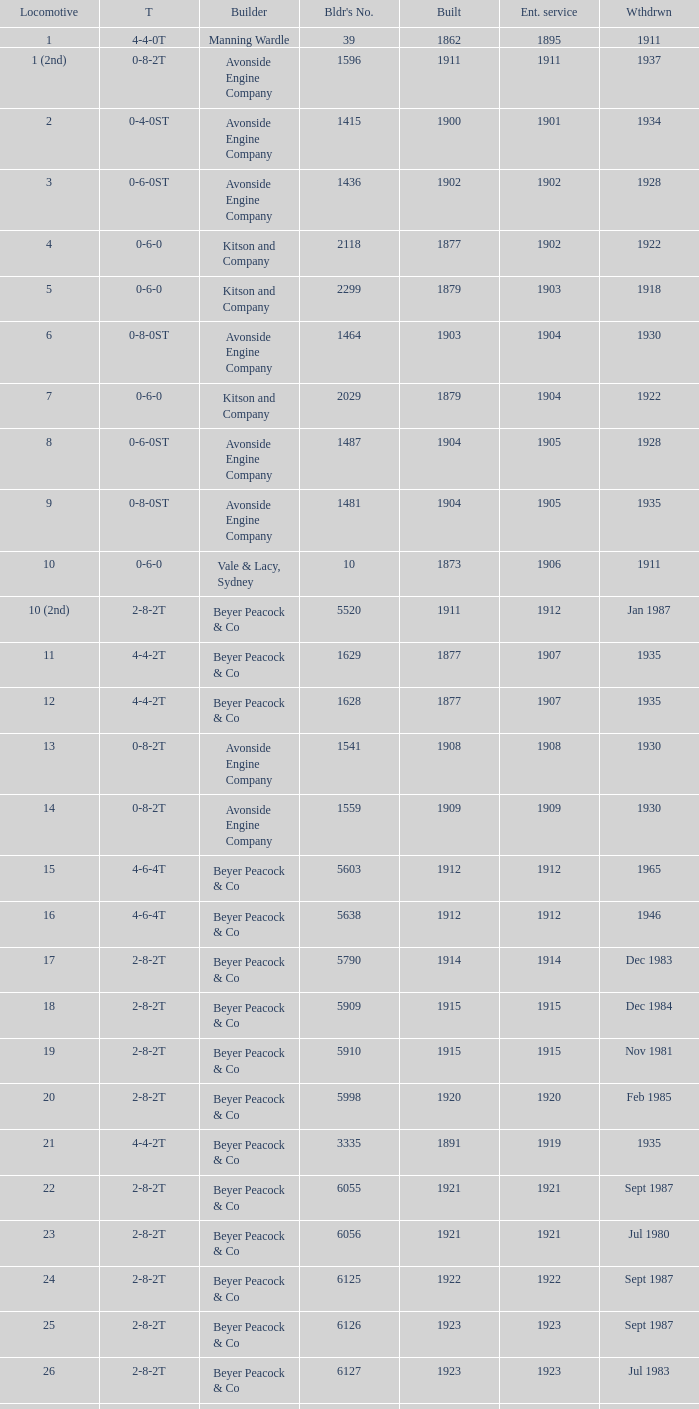Could you parse the entire table as a dict? {'header': ['Locomotive', 'T', 'Builder', "Bldr's No.", 'Built', 'Ent. service', 'Wthdrwn'], 'rows': [['1', '4-4-0T', 'Manning Wardle', '39', '1862', '1895', '1911'], ['1 (2nd)', '0-8-2T', 'Avonside Engine Company', '1596', '1911', '1911', '1937'], ['2', '0-4-0ST', 'Avonside Engine Company', '1415', '1900', '1901', '1934'], ['3', '0-6-0ST', 'Avonside Engine Company', '1436', '1902', '1902', '1928'], ['4', '0-6-0', 'Kitson and Company', '2118', '1877', '1902', '1922'], ['5', '0-6-0', 'Kitson and Company', '2299', '1879', '1903', '1918'], ['6', '0-8-0ST', 'Avonside Engine Company', '1464', '1903', '1904', '1930'], ['7', '0-6-0', 'Kitson and Company', '2029', '1879', '1904', '1922'], ['8', '0-6-0ST', 'Avonside Engine Company', '1487', '1904', '1905', '1928'], ['9', '0-8-0ST', 'Avonside Engine Company', '1481', '1904', '1905', '1935'], ['10', '0-6-0', 'Vale & Lacy, Sydney', '10', '1873', '1906', '1911'], ['10 (2nd)', '2-8-2T', 'Beyer Peacock & Co', '5520', '1911', '1912', 'Jan 1987'], ['11', '4-4-2T', 'Beyer Peacock & Co', '1629', '1877', '1907', '1935'], ['12', '4-4-2T', 'Beyer Peacock & Co', '1628', '1877', '1907', '1935'], ['13', '0-8-2T', 'Avonside Engine Company', '1541', '1908', '1908', '1930'], ['14', '0-8-2T', 'Avonside Engine Company', '1559', '1909', '1909', '1930'], ['15', '4-6-4T', 'Beyer Peacock & Co', '5603', '1912', '1912', '1965'], ['16', '4-6-4T', 'Beyer Peacock & Co', '5638', '1912', '1912', '1946'], ['17', '2-8-2T', 'Beyer Peacock & Co', '5790', '1914', '1914', 'Dec 1983'], ['18', '2-8-2T', 'Beyer Peacock & Co', '5909', '1915', '1915', 'Dec 1984'], ['19', '2-8-2T', 'Beyer Peacock & Co', '5910', '1915', '1915', 'Nov 1981'], ['20', '2-8-2T', 'Beyer Peacock & Co', '5998', '1920', '1920', 'Feb 1985'], ['21', '4-4-2T', 'Beyer Peacock & Co', '3335', '1891', '1919', '1935'], ['22', '2-8-2T', 'Beyer Peacock & Co', '6055', '1921', '1921', 'Sept 1987'], ['23', '2-8-2T', 'Beyer Peacock & Co', '6056', '1921', '1921', 'Jul 1980'], ['24', '2-8-2T', 'Beyer Peacock & Co', '6125', '1922', '1922', 'Sept 1987'], ['25', '2-8-2T', 'Beyer Peacock & Co', '6126', '1923', '1923', 'Sept 1987'], ['26', '2-8-2T', 'Beyer Peacock & Co', '6127', '1923', '1923', 'Jul 1983'], ['27', '2-8-2T', 'Beyer Peacock & Co', '6137', '1923', '1923', 'Mar 1987'], ['28', '2-8-2T', 'Beyer Peacock & Co', '6138', '1923', '1923', 'Dec 1983'], ['29', '4-6-4T', 'Beyer Peacock & Co', '6139', '1923', '1923', '1965'], ['30', '2-8-2T', 'Beyer Peacock & Co', '6294', '1926', '1926', 'Sept 1987'], ['31', '2-8-2T', 'Beyer Peacock & Co', '5295', '1926', '1926', 'Jun 1984']]} How many years entered service when there were 13 locomotives? 1.0. 